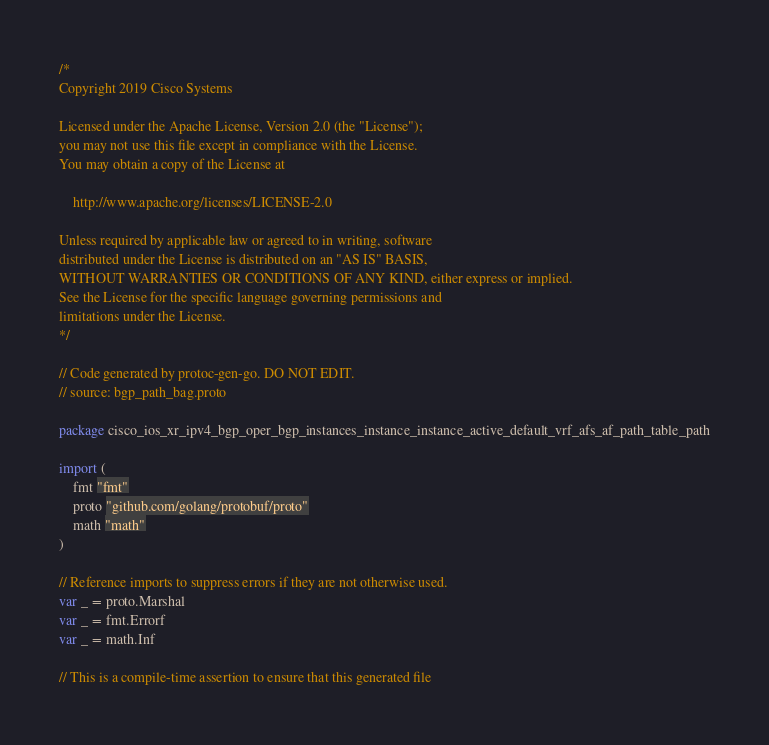<code> <loc_0><loc_0><loc_500><loc_500><_Go_>/*
Copyright 2019 Cisco Systems

Licensed under the Apache License, Version 2.0 (the "License");
you may not use this file except in compliance with the License.
You may obtain a copy of the License at

    http://www.apache.org/licenses/LICENSE-2.0

Unless required by applicable law or agreed to in writing, software
distributed under the License is distributed on an "AS IS" BASIS,
WITHOUT WARRANTIES OR CONDITIONS OF ANY KIND, either express or implied.
See the License for the specific language governing permissions and
limitations under the License.
*/

// Code generated by protoc-gen-go. DO NOT EDIT.
// source: bgp_path_bag.proto

package cisco_ios_xr_ipv4_bgp_oper_bgp_instances_instance_instance_active_default_vrf_afs_af_path_table_path

import (
	fmt "fmt"
	proto "github.com/golang/protobuf/proto"
	math "math"
)

// Reference imports to suppress errors if they are not otherwise used.
var _ = proto.Marshal
var _ = fmt.Errorf
var _ = math.Inf

// This is a compile-time assertion to ensure that this generated file</code> 